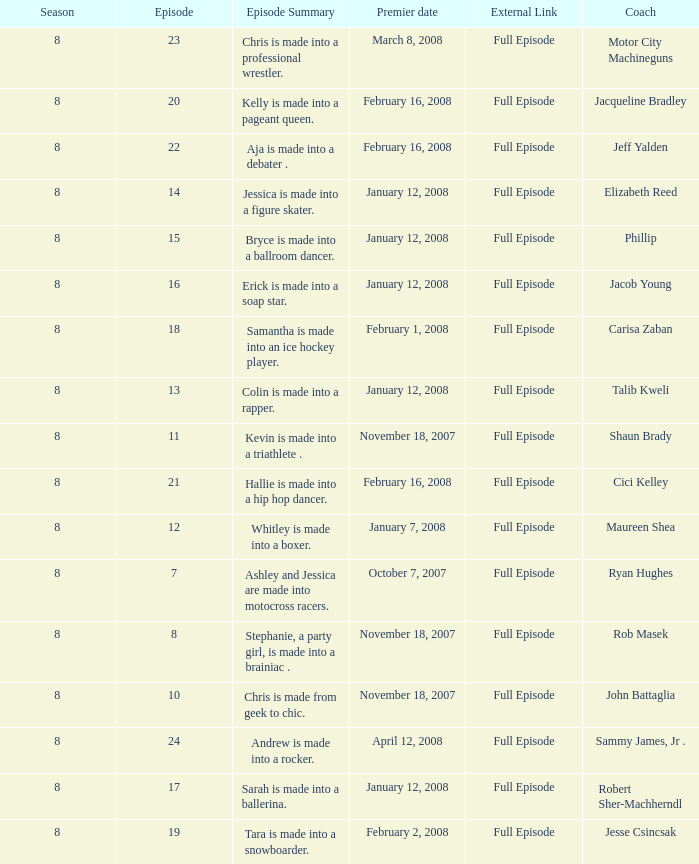Who was the coach for episode 15? Phillip. 